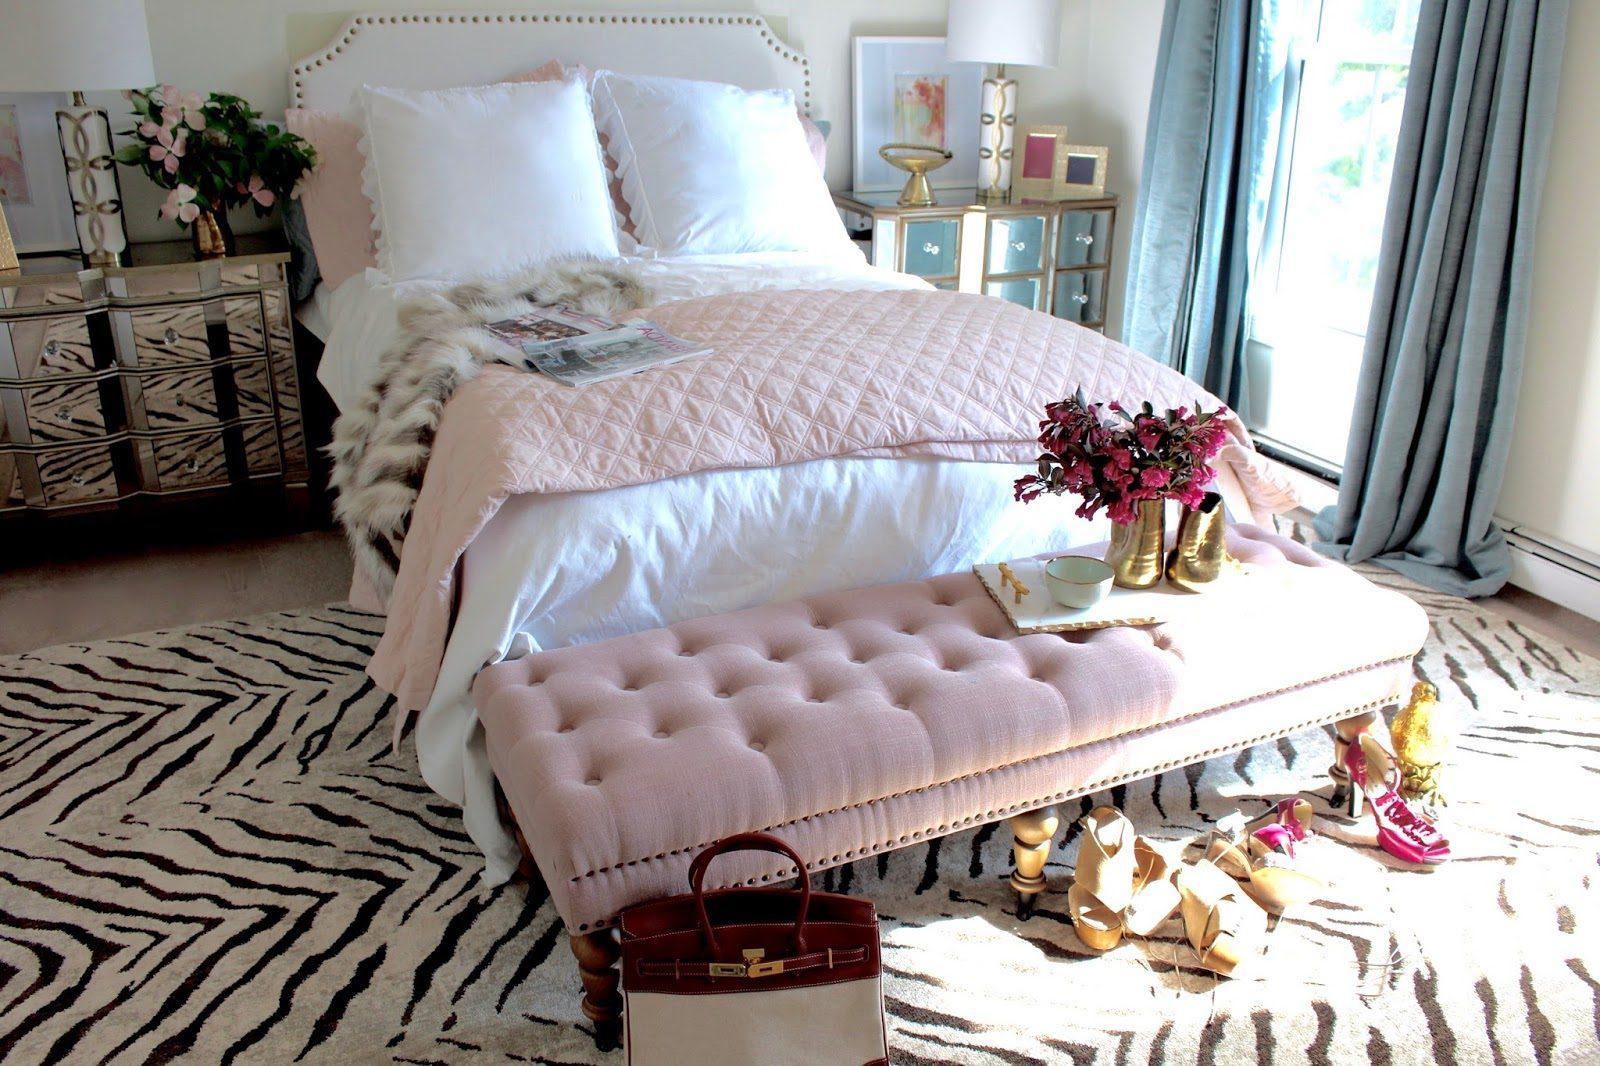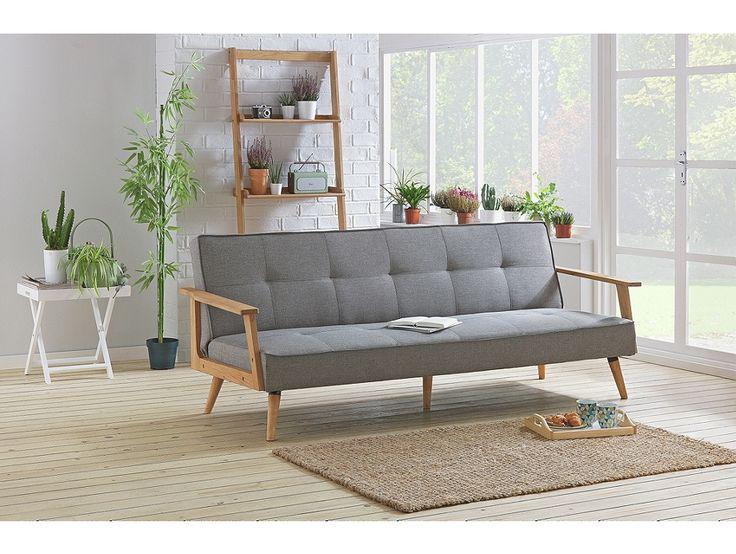The first image is the image on the left, the second image is the image on the right. For the images displayed, is the sentence "There is a single table lamp with a white shade to the right of a couch in the left image." factually correct? Answer yes or no. No. The first image is the image on the left, the second image is the image on the right. Considering the images on both sides, is "The room on the left features a large printed rug, a vase filled with hot pink flowers, and an upholstered, tufted piece of furniture." valid? Answer yes or no. Yes. 